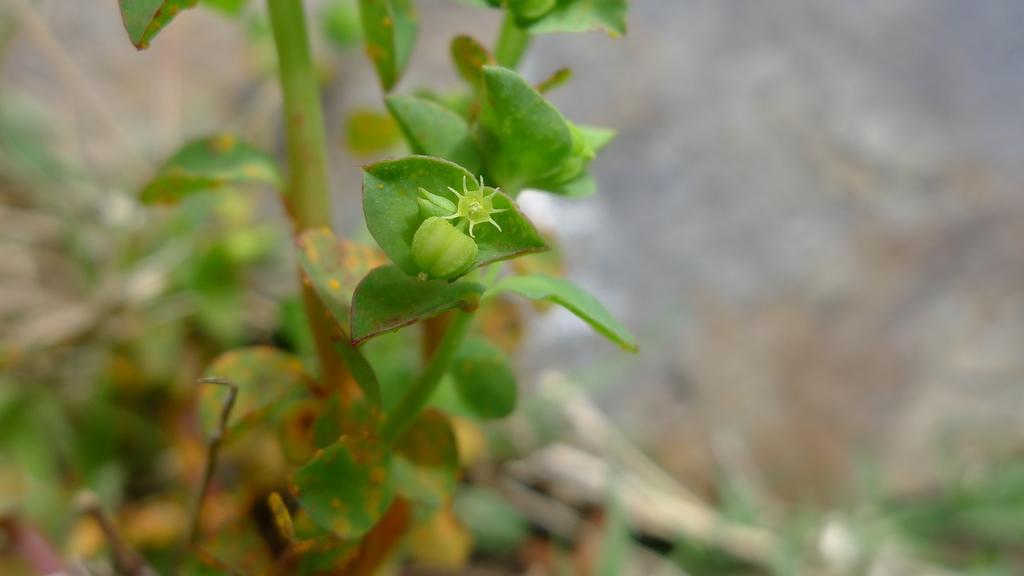How would you summarize this image in a sentence or two? In this image I can see the plant and there is a blurred background. 